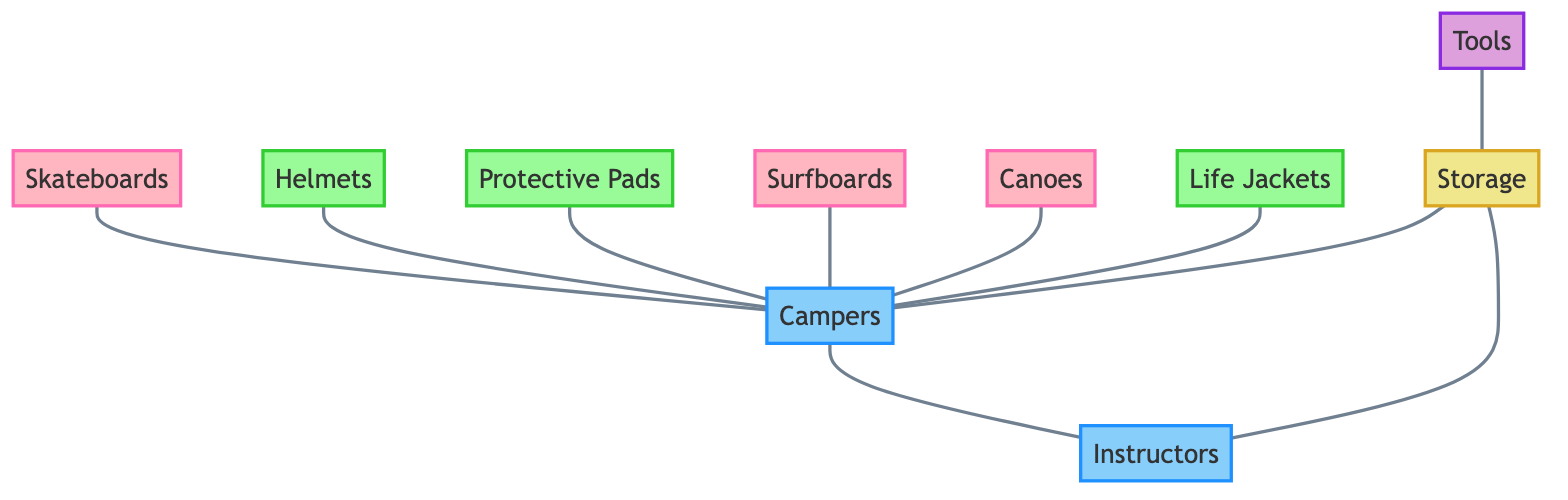What are the equipment nodes in the diagram? The equipment nodes are identified by their category as "Equipment". By looking at the node definitions, the names associated with this category include Skateboards, Surfboards, and Canoes.
Answer: Skateboards, Surfboards, Canoes How many safety gear items are listed? The safety gear items are represented as nodes in the "Safety Gear" category. Upon reviewing the nodes, there are three items: Helmets, Protective Pads, and Life Jackets. Thus, we count them to find there are three safety gear items.
Answer: 3 Which nodes are connected to the campers? To find this, we need to examine the edges connected to the node representing Campers. It has edges leading to Skateboards, Helmets, Protective Pads, Surfboards, Canoes, Life Jackets, and Instructors. Thus, the connected nodes include all those listed.
Answer: Skateboards, Helmets, Protective Pads, Surfboards, Canoes, Life Jackets, Instructors Are instructors connected to any equipment? We check the connections of the Instructors node. The edges indicate that Instructors are connected only to Campers and Storage. Since there are no edges linking Instructors to the Equipment nodes, the answer is determined.
Answer: No What is the relationship between tools and storage? The edge between Tools and Storage indicates a direct connection, which signifies that Tools are used or stored in Storage. This is a straightforward relationship as defined in the edges.
Answer: Tools are associated with Storage How many nodes are classified under "People"? The nodes classified as "People" include Campers and Instructors. This makes a total of two distinct nodes under this category when counted.
Answer: 2 Which safety gear is exclusively connected to campers? Evaluating the edges shows Helmets, Protective Pads, and Life Jackets are solely connected to the Campers, with no other connections leading to them. Thus, these items can be labeled as exclusively camper-connected safety gear.
Answer: Helmets, Protective Pads, Life Jackets Is storage connected to any people nodes? Yes, by analyzing the edges, Storage has connections leading directly to both Campers and Instructors, establishing a relationship between these entities and Storage.
Answer: Yes How many edges are represented in the diagram? To find the number of edges, we can simply count them as described in the edges section. There are a total of ten edges connecting various nodes.
Answer: 10 